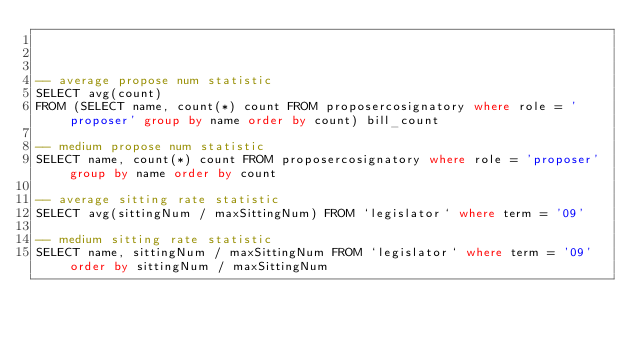Convert code to text. <code><loc_0><loc_0><loc_500><loc_500><_SQL_>


-- average propose num statistic
SELECT avg(count)
FROM (SELECT name, count(*) count FROM proposercosignatory where role = 'proposer' group by name order by count) bill_count

-- medium propose num statistic
SELECT name, count(*) count FROM proposercosignatory where role = 'proposer' group by name order by count

-- average sitting rate statistic
SELECT avg(sittingNum / maxSittingNum) FROM `legislator` where term = '09'

-- medium sitting rate statistic
SELECT name, sittingNum / maxSittingNum FROM `legislator` where term = '09' order by sittingNum / maxSittingNum</code> 